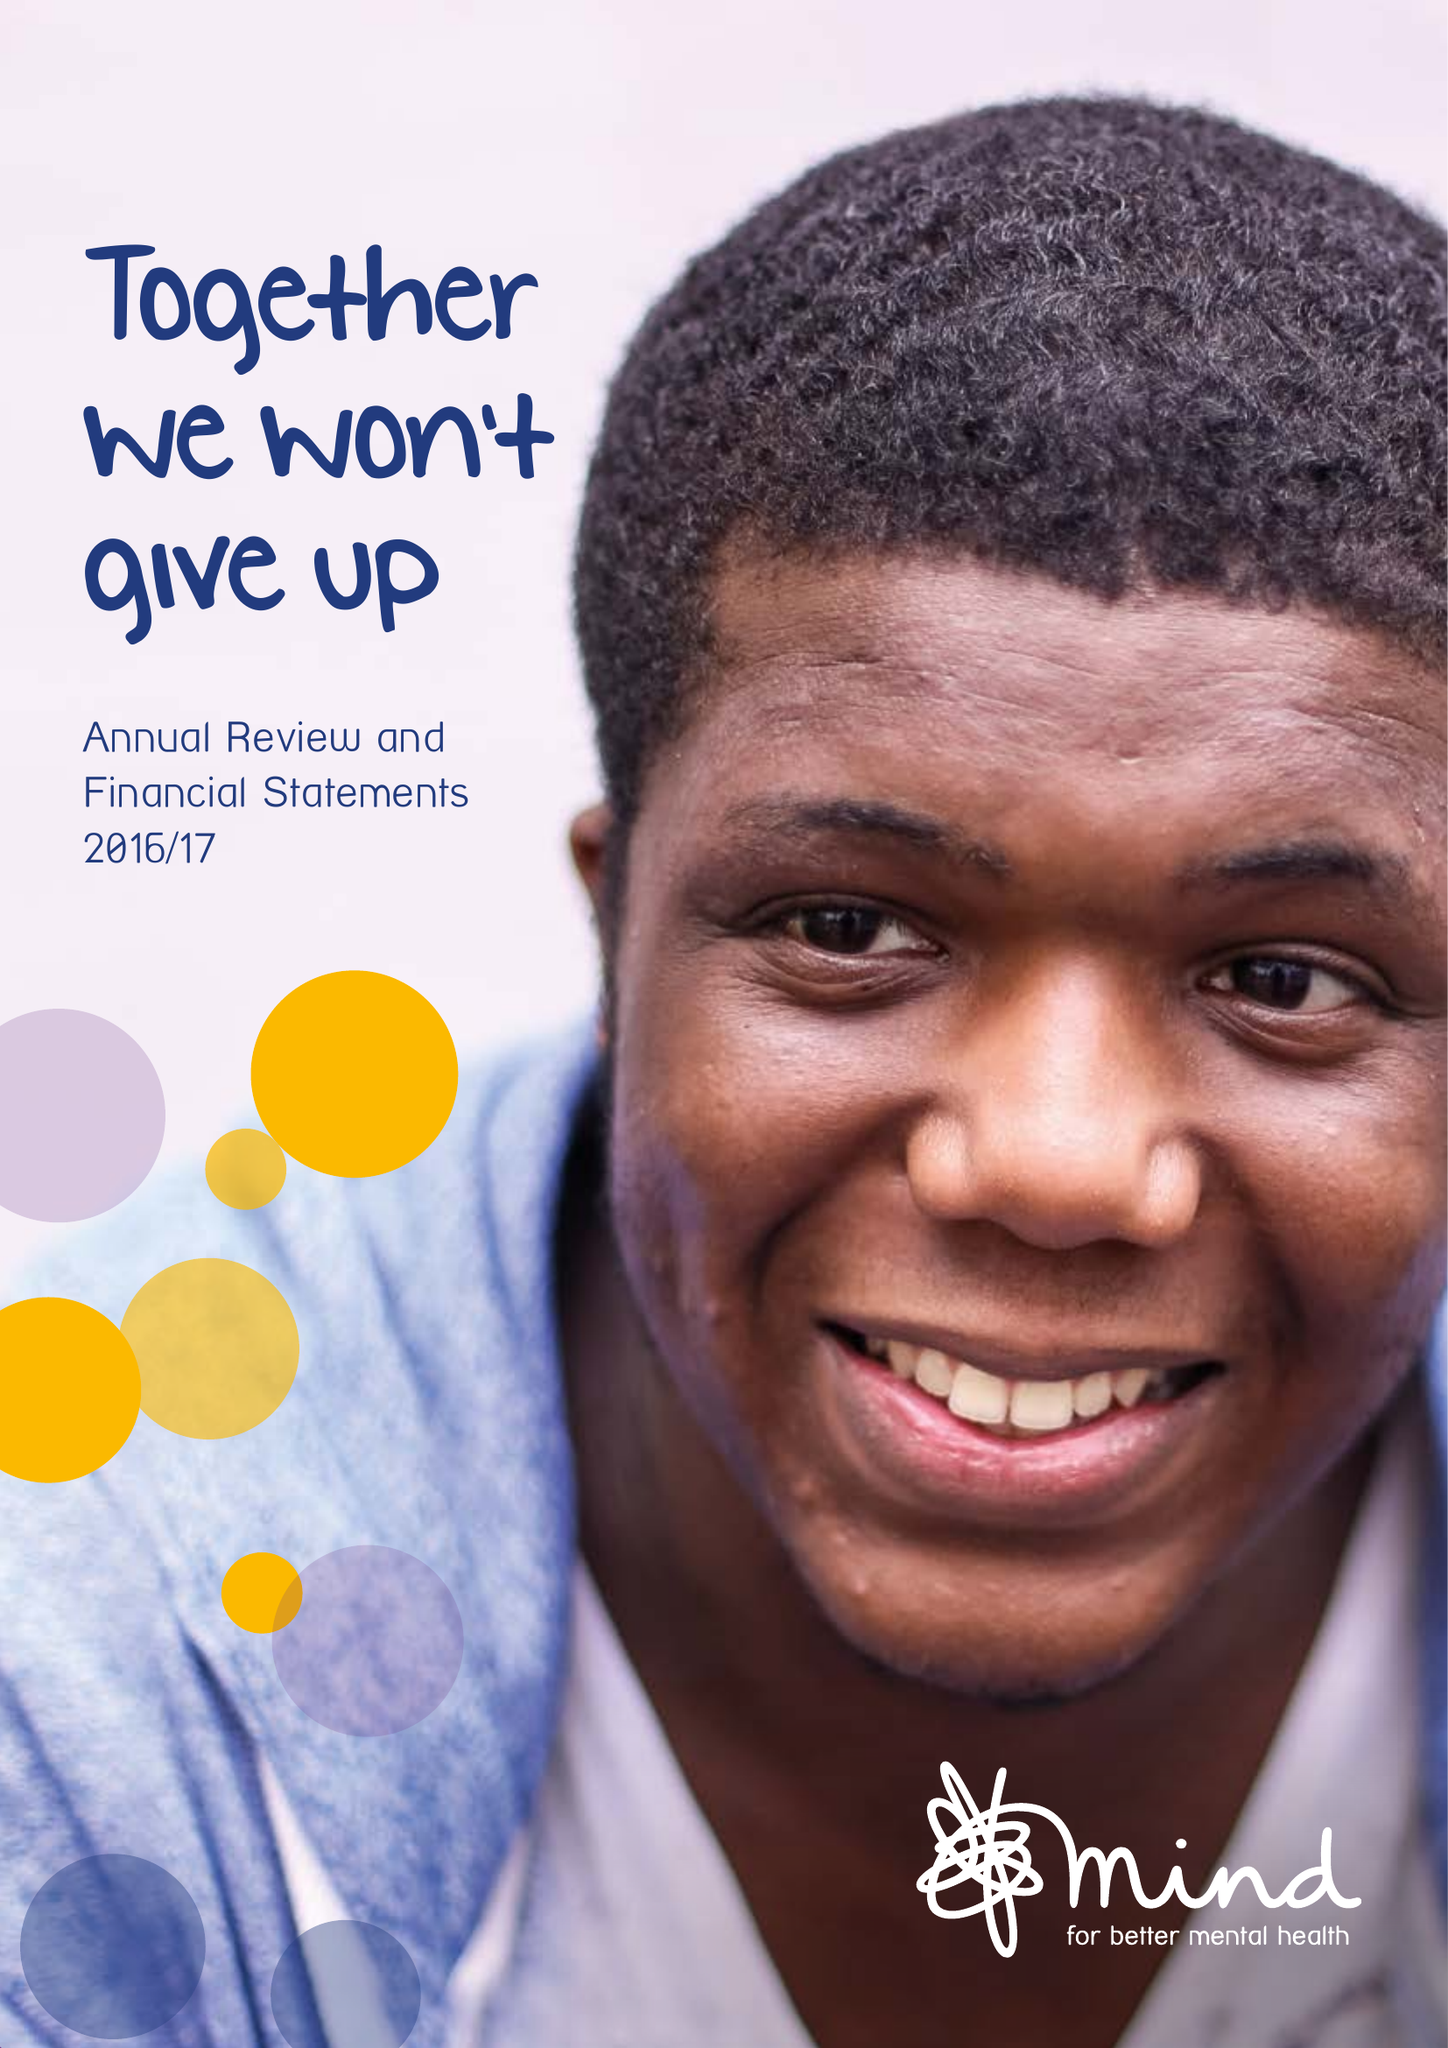What is the value for the address__post_town?
Answer the question using a single word or phrase. LONDON 